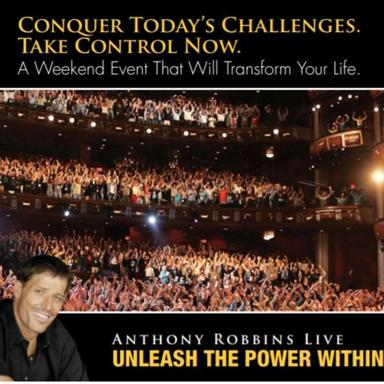Can you describe the visual elements used in the poster and their significance? The poster uses a powerful juxtaposition of a large, engaged audience and a prominent image of Tony Robbins smiling, which together convey the magnitude and impact of the event. The dark ambiance of the hall contrasts with the highlighted crowd and enhances the focus on the communal and electrifying atmosphere. The text 'Conquer Today's Challenges. Take Control Now.' further adds motivational context, urging potential attendees toward self-improvement and personal empowerment. 